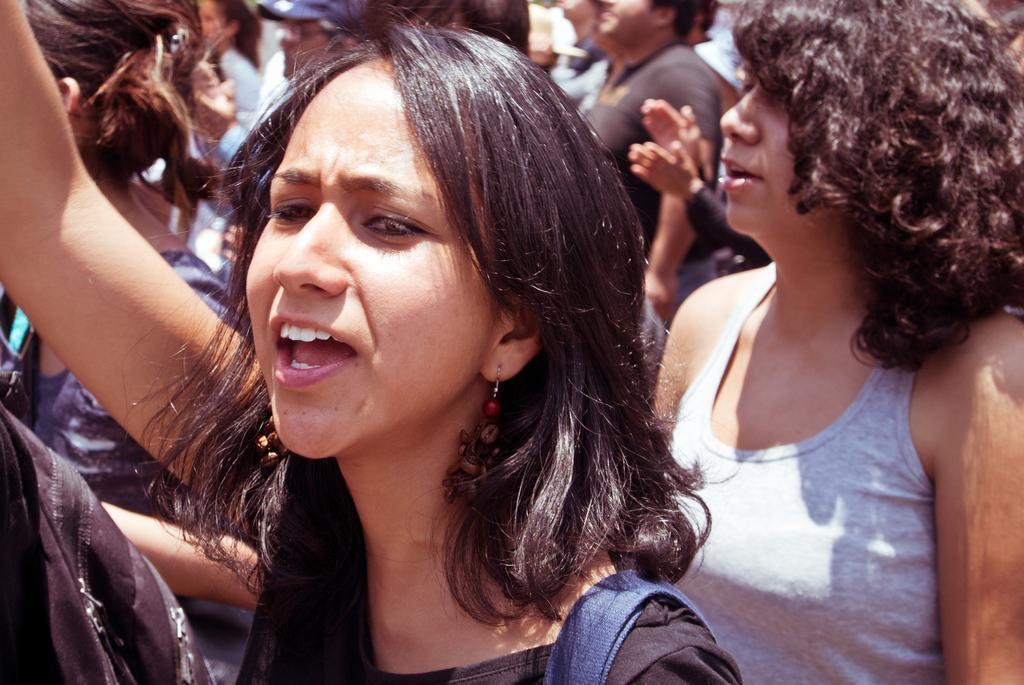How would you summarize this image in a sentence or two? In this picture I can see 2 women standing in front and in the background I can see number of people and I see that it is a bit blurry on the top of this picture. 